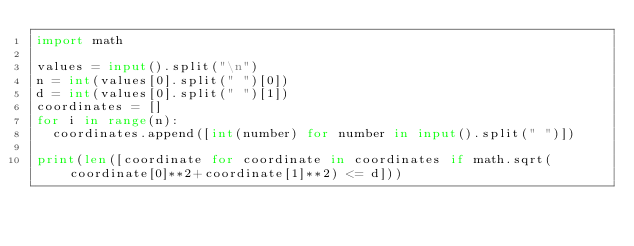<code> <loc_0><loc_0><loc_500><loc_500><_Python_>import math

values = input().split("\n")
n = int(values[0].split(" ")[0])
d = int(values[0].split(" ")[1])
coordinates = []
for i in range(n):
  coordinates.append([int(number) for number in input().split(" ")])

print(len([coordinate for coordinate in coordinates if math.sqrt(coordinate[0]**2+coordinate[1]**2) <= d]))</code> 